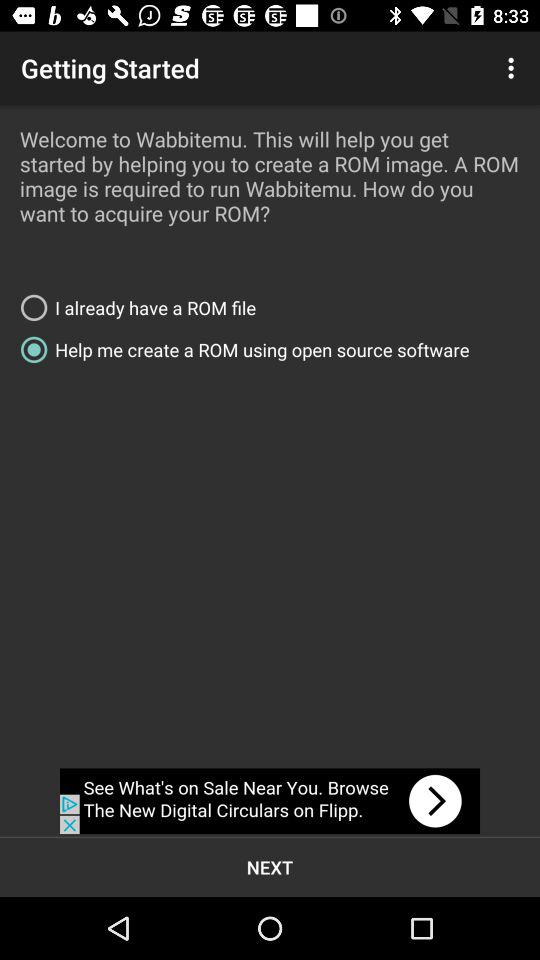How many RADIO_BUTTONs are there on this screen?
Answer the question using a single word or phrase. 2 